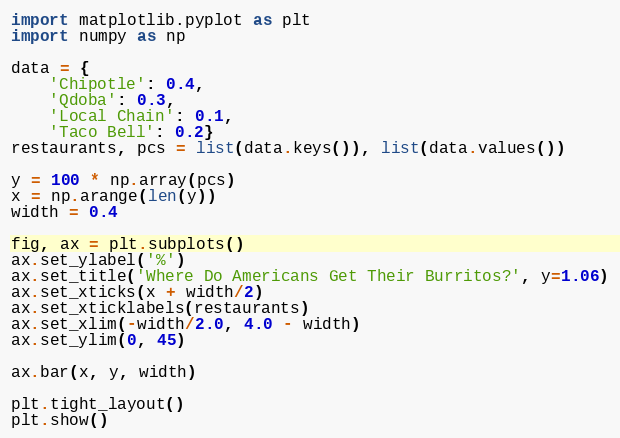<code> <loc_0><loc_0><loc_500><loc_500><_Python_>import matplotlib.pyplot as plt
import numpy as np

data = {
    'Chipotle': 0.4,
    'Qdoba': 0.3,
    'Local Chain': 0.1, 
    'Taco Bell': 0.2}
restaurants, pcs = list(data.keys()), list(data.values())

y = 100 * np.array(pcs)
x = np.arange(len(y))
width = 0.4

fig, ax = plt.subplots()
ax.set_ylabel('%')
ax.set_title('Where Do Americans Get Their Burritos?', y=1.06)
ax.set_xticks(x + width/2)
ax.set_xticklabels(restaurants)
ax.set_xlim(-width/2.0, 4.0 - width)
ax.set_ylim(0, 45)

ax.bar(x, y, width)

plt.tight_layout()
plt.show()
</code> 